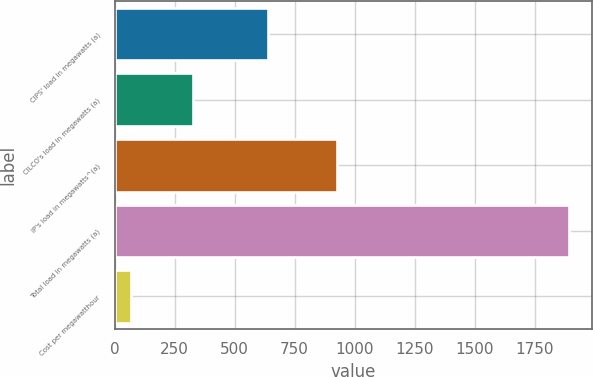Convert chart to OTSL. <chart><loc_0><loc_0><loc_500><loc_500><bar_chart><fcel>CIPS' load in megawatts (a)<fcel>CILCO's load in megawatts (a)<fcel>IP's load in megawatts^(a)<fcel>Total load in megawatts (a)<fcel>Cost per megawatthour<nl><fcel>639<fcel>328<fcel>928<fcel>1895<fcel>66.05<nl></chart> 